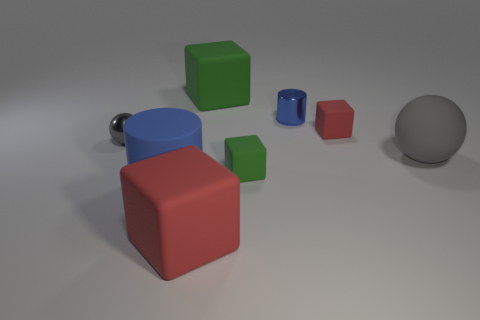Subtract all tiny red rubber cubes. How many cubes are left? 3 Add 2 cylinders. How many objects exist? 10 Subtract all cyan cylinders. How many green cubes are left? 2 Subtract all green cubes. How many cubes are left? 2 Subtract all cylinders. How many objects are left? 6 Add 2 big spheres. How many big spheres are left? 3 Add 6 small blue blocks. How many small blue blocks exist? 6 Subtract 0 yellow blocks. How many objects are left? 8 Subtract all purple cylinders. Subtract all gray blocks. How many cylinders are left? 2 Subtract all brown metallic things. Subtract all green blocks. How many objects are left? 6 